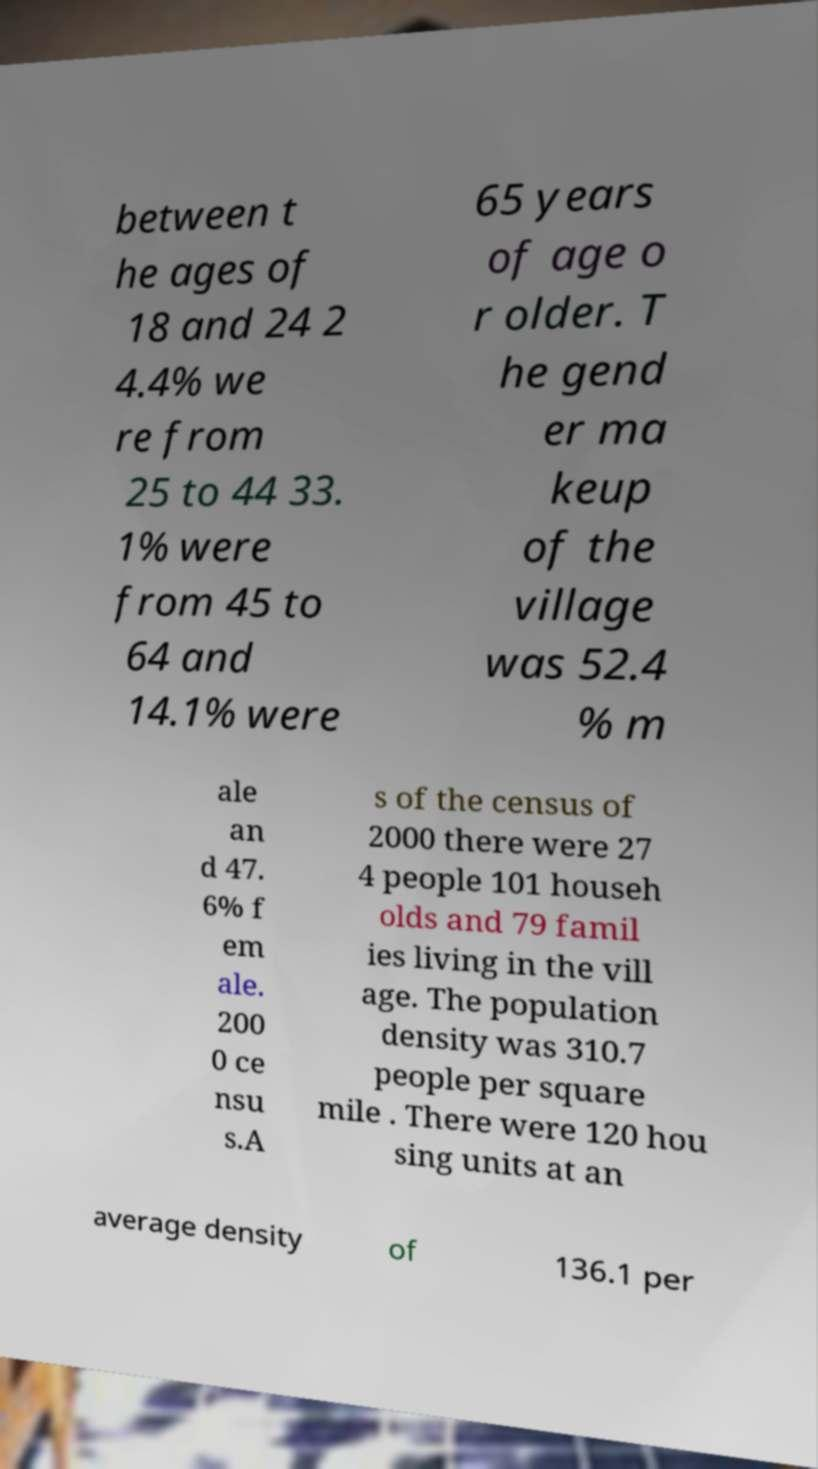Can you read and provide the text displayed in the image?This photo seems to have some interesting text. Can you extract and type it out for me? between t he ages of 18 and 24 2 4.4% we re from 25 to 44 33. 1% were from 45 to 64 and 14.1% were 65 years of age o r older. T he gend er ma keup of the village was 52.4 % m ale an d 47. 6% f em ale. 200 0 ce nsu s.A s of the census of 2000 there were 27 4 people 101 househ olds and 79 famil ies living in the vill age. The population density was 310.7 people per square mile . There were 120 hou sing units at an average density of 136.1 per 